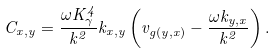<formula> <loc_0><loc_0><loc_500><loc_500>C _ { x , y } = \frac { \omega K ^ { 4 } _ { \gamma } } { k ^ { 2 } } k _ { x , y } \left ( v _ { g ( y , x ) } - \frac { \omega k _ { y , x } } { k ^ { 2 } } \right ) .</formula> 